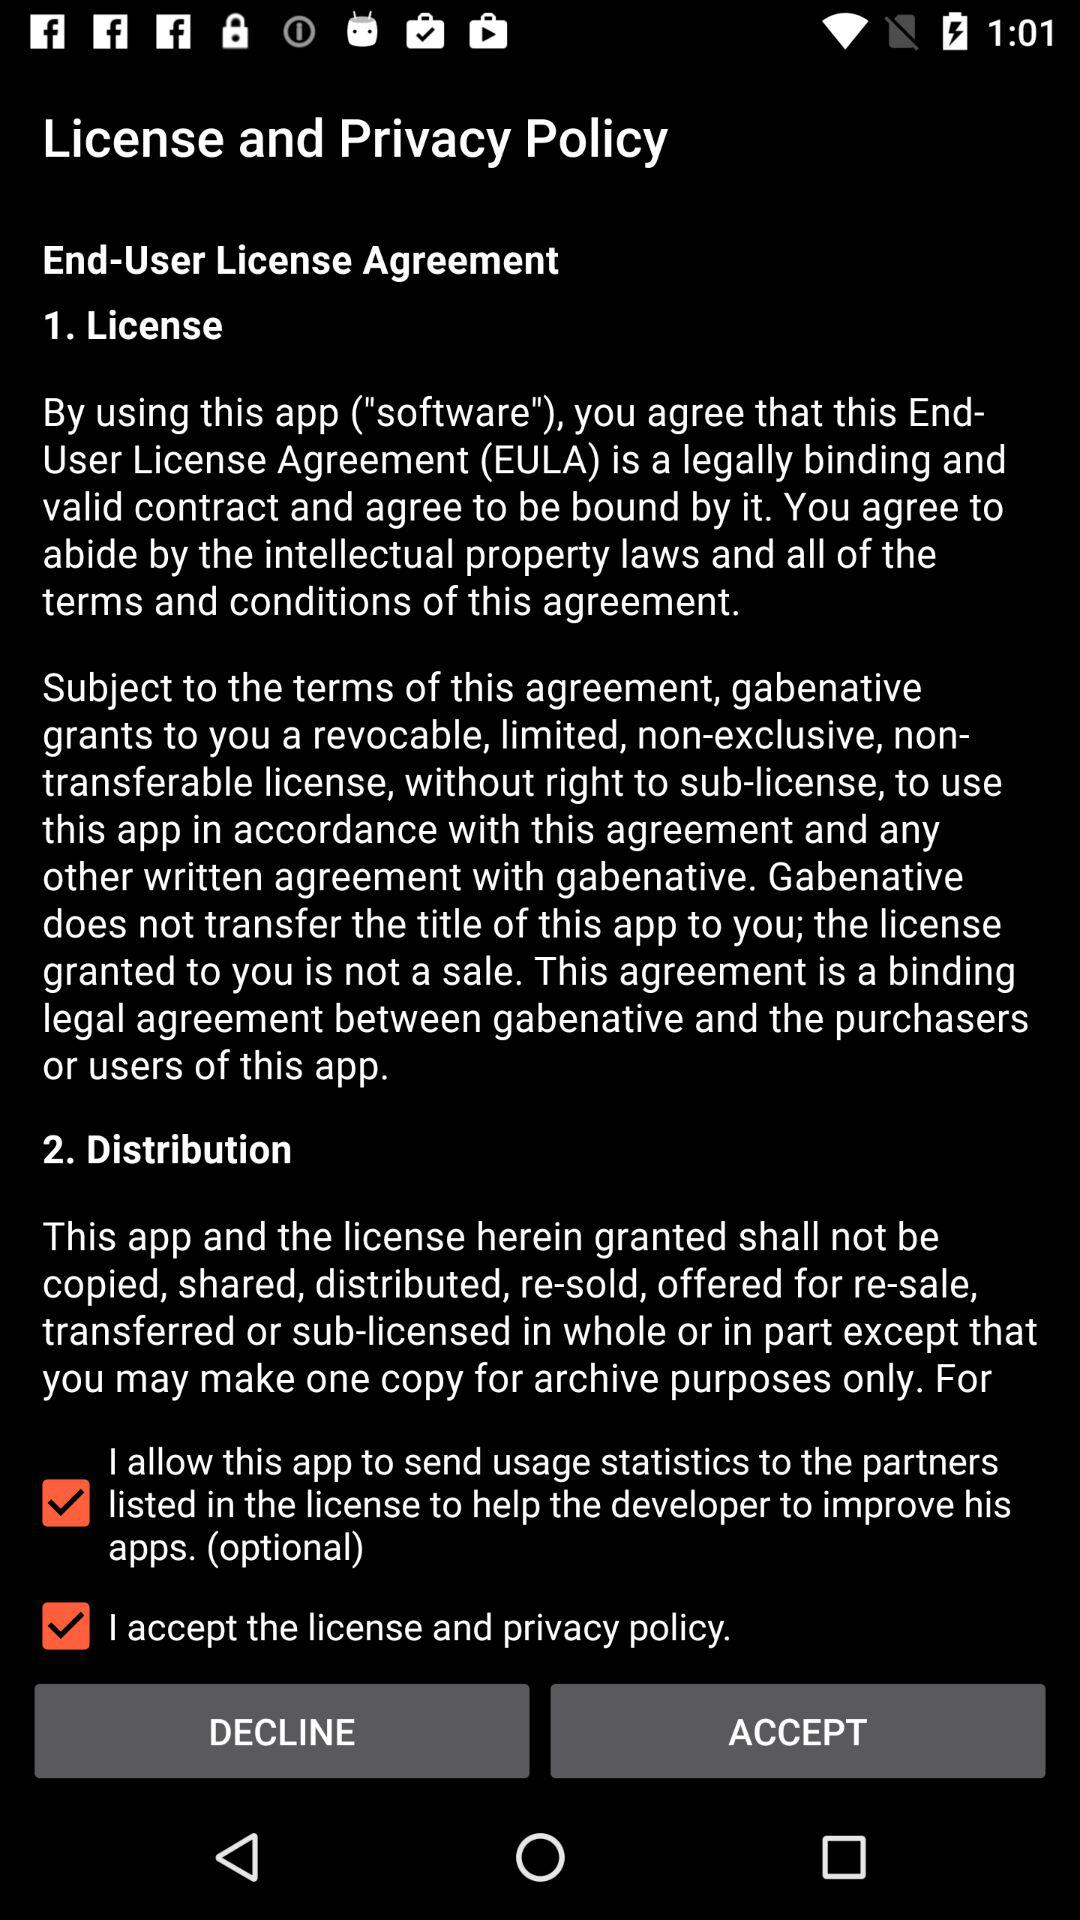Is "I accept the license and privacy policy" checked or unchecked? "I accept the license and privacy policy" is checked. 